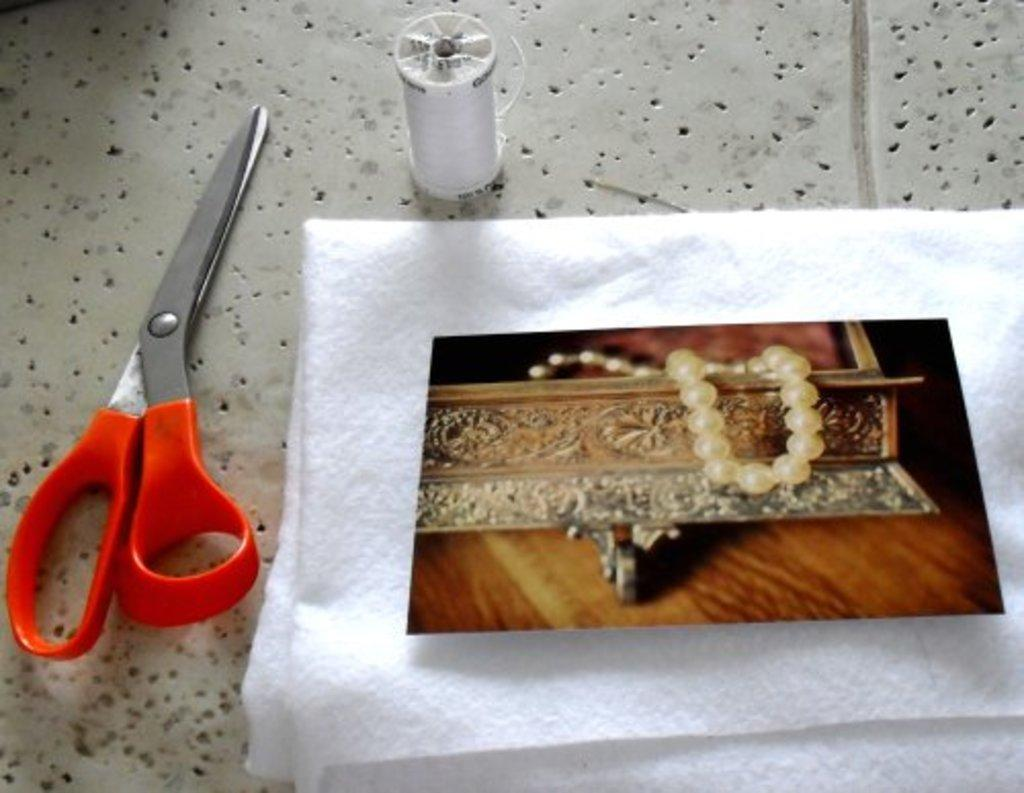What object is on the table in the image? There is a scissor on the table. What else can be found on the table? There is tissue paper, thread, and a photo on the table. What is depicted in the photo? The photo contains a book and a wooden table. What type of berry is being used to stop the scissor from cutting the thread? There is no berry present in the image, and the scissor is not cutting the thread. 